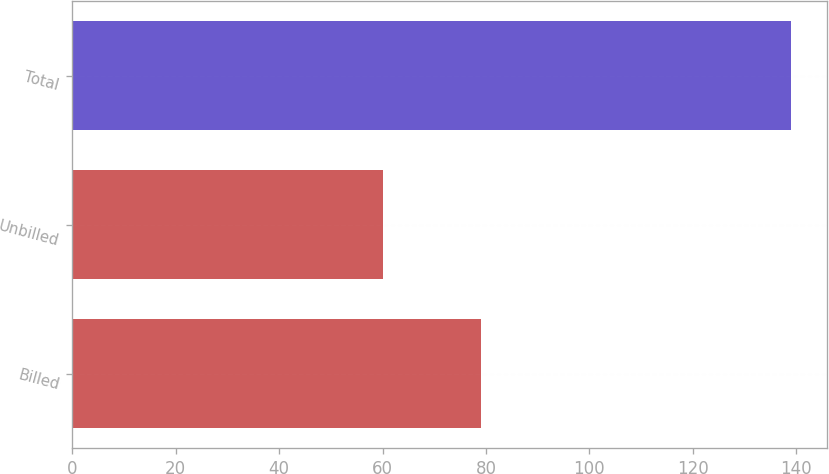Convert chart to OTSL. <chart><loc_0><loc_0><loc_500><loc_500><bar_chart><fcel>Billed<fcel>Unbilled<fcel>Total<nl><fcel>79<fcel>60<fcel>139<nl></chart> 